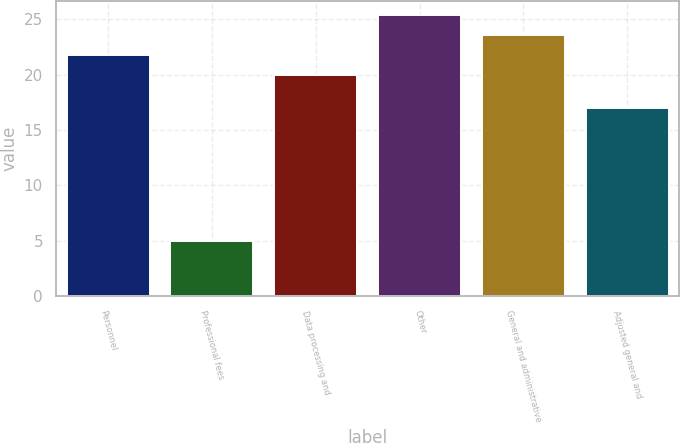Convert chart to OTSL. <chart><loc_0><loc_0><loc_500><loc_500><bar_chart><fcel>Personnel<fcel>Professional fees<fcel>Data processing and<fcel>Other<fcel>General and administrative<fcel>Adjusted general and<nl><fcel>21.8<fcel>5<fcel>20<fcel>25.4<fcel>23.6<fcel>17<nl></chart> 